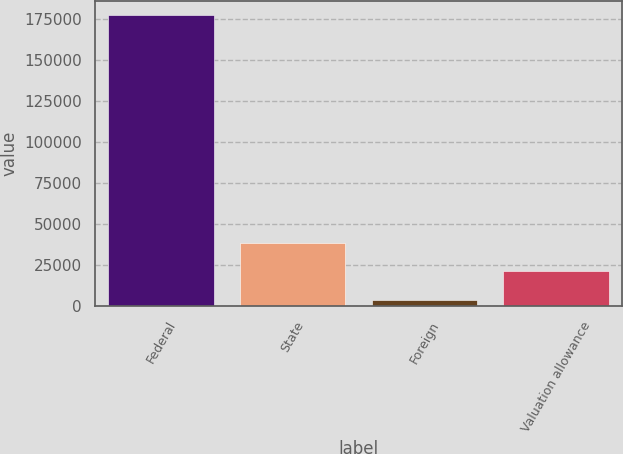<chart> <loc_0><loc_0><loc_500><loc_500><bar_chart><fcel>Federal<fcel>State<fcel>Foreign<fcel>Valuation allowance<nl><fcel>177372<fcel>38635.2<fcel>3951<fcel>21293.1<nl></chart> 